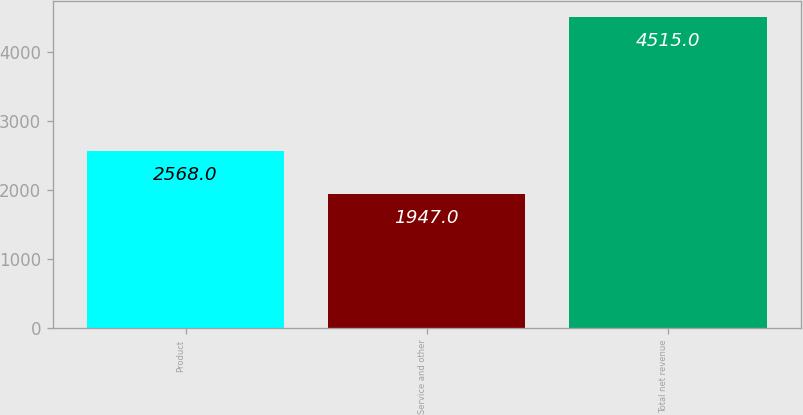Convert chart. <chart><loc_0><loc_0><loc_500><loc_500><bar_chart><fcel>Product<fcel>Service and other<fcel>Total net revenue<nl><fcel>2568<fcel>1947<fcel>4515<nl></chart> 